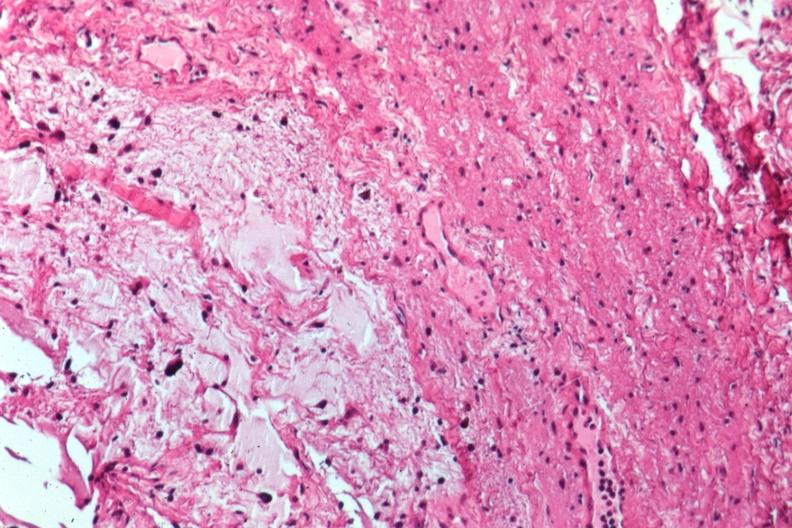s optic nerve present?
Answer the question using a single word or phrase. Yes 